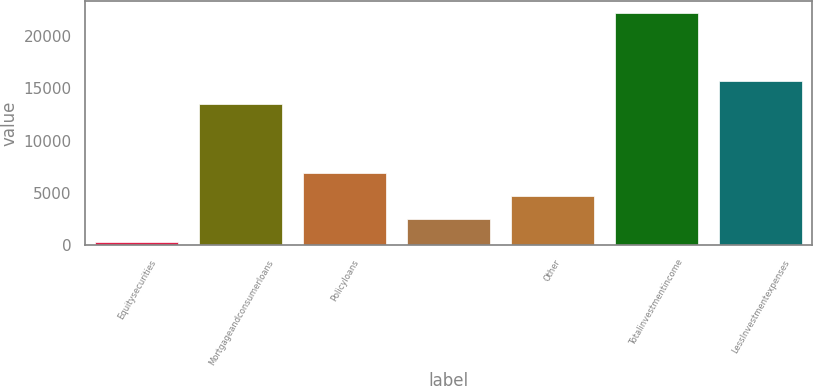<chart> <loc_0><loc_0><loc_500><loc_500><bar_chart><fcel>Equitysecurities<fcel>Mortgageandconsumerloans<fcel>Policyloans<fcel>Unnamed: 3<fcel>Other<fcel>Totalinvestmentincome<fcel>LessInvestmentexpenses<nl><fcel>279<fcel>13482.6<fcel>6880.8<fcel>2479.6<fcel>4680.2<fcel>22285<fcel>15683.2<nl></chart> 